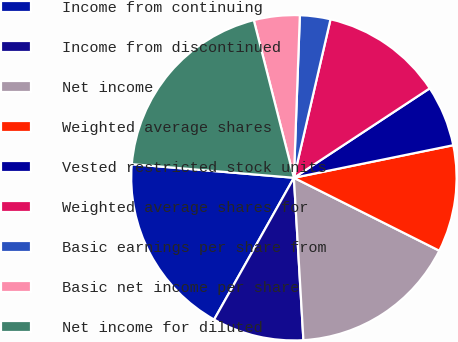Convert chart to OTSL. <chart><loc_0><loc_0><loc_500><loc_500><pie_chart><fcel>Income from continuing<fcel>Income from discontinued<fcel>Net income<fcel>Weighted average shares<fcel>Vested restricted stock units<fcel>Weighted average shares for<fcel>Basic earnings per share from<fcel>Basic net income per share<fcel>Net income for diluted<nl><fcel>18.18%<fcel>9.09%<fcel>16.67%<fcel>10.61%<fcel>6.06%<fcel>12.12%<fcel>3.03%<fcel>4.55%<fcel>19.7%<nl></chart> 